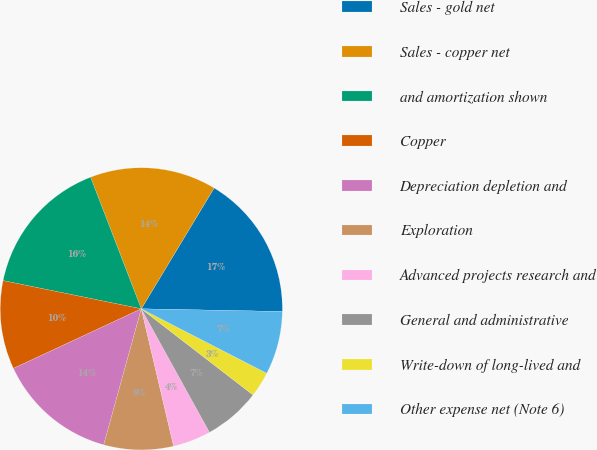Convert chart to OTSL. <chart><loc_0><loc_0><loc_500><loc_500><pie_chart><fcel>Sales - gold net<fcel>Sales - copper net<fcel>and amortization shown<fcel>Copper<fcel>Depreciation depletion and<fcel>Exploration<fcel>Advanced projects research and<fcel>General and administrative<fcel>Write-down of long-lived and<fcel>Other expense net (Note 6)<nl><fcel>16.67%<fcel>14.49%<fcel>15.94%<fcel>10.14%<fcel>13.77%<fcel>7.97%<fcel>4.35%<fcel>6.52%<fcel>2.9%<fcel>7.25%<nl></chart> 